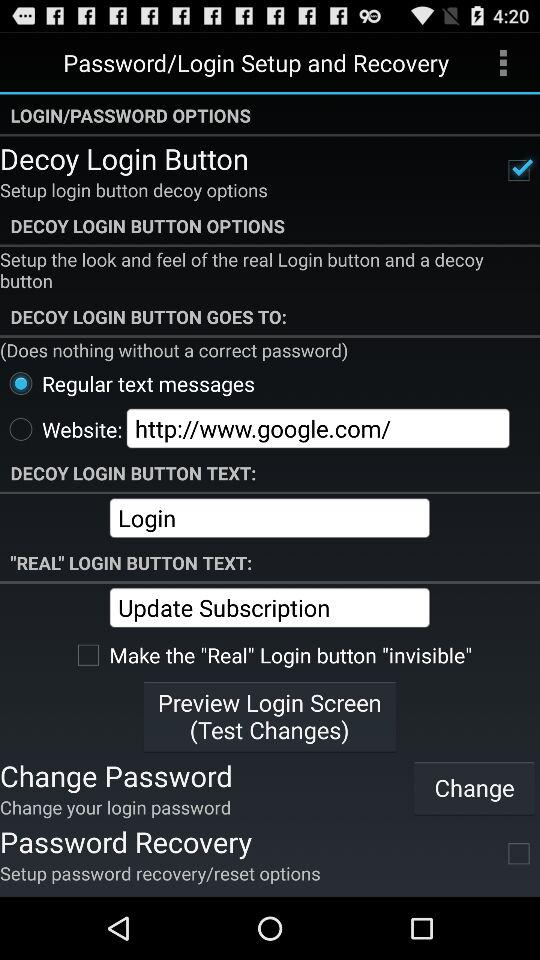What is the status of the "Decoy Login Button"? The status is "on". 